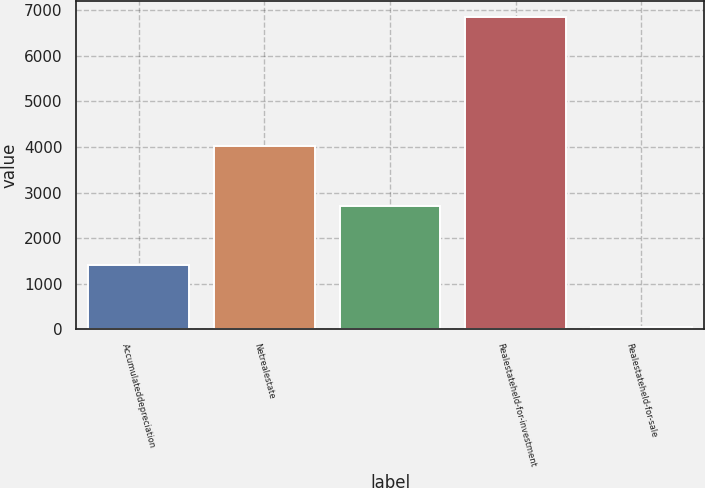<chart> <loc_0><loc_0><loc_500><loc_500><bar_chart><fcel>Accumulateddepreciation<fcel>Netrealestate<fcel>Unnamed: 2<fcel>Realestateheld-for-investment<fcel>Realestateheld-for-sale<nl><fcel>1408<fcel>4027<fcel>2698<fcel>6852<fcel>44<nl></chart> 